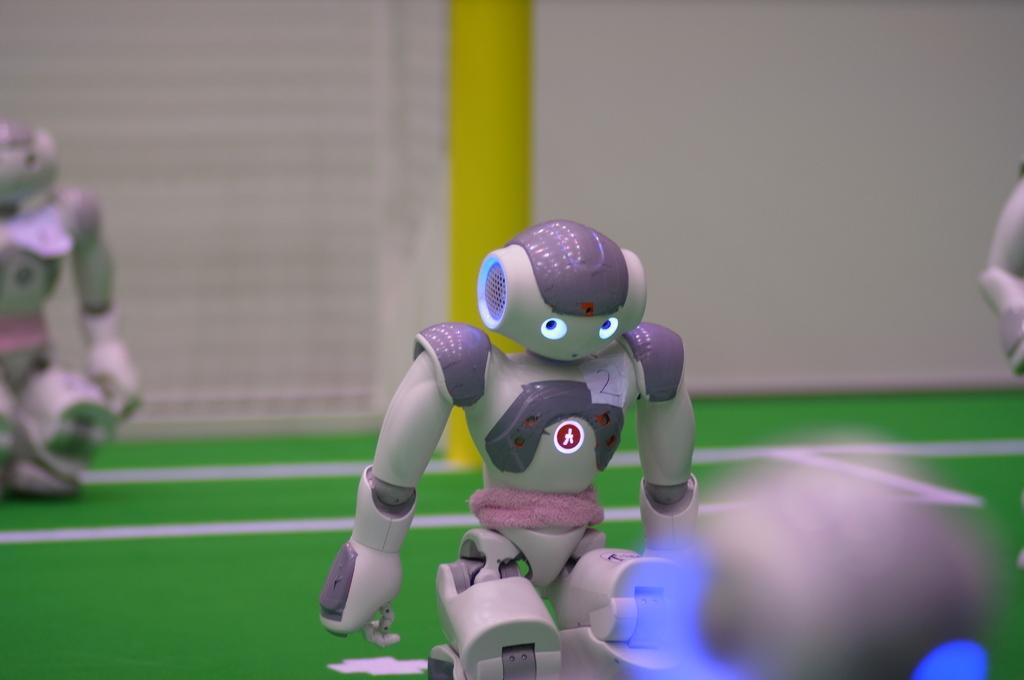Can you describe this image briefly? In this image there is a small robot in the middle. On the left side there is another robot in the background. Behind the robot there is a pole. 